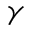<formula> <loc_0><loc_0><loc_500><loc_500>\gamma</formula> 